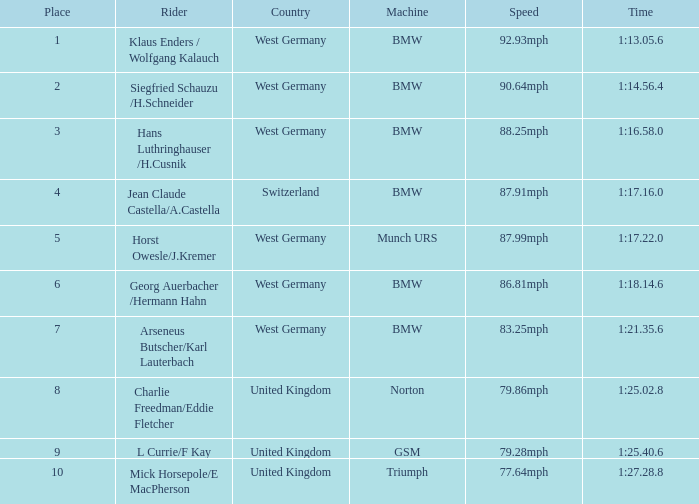Which places have points larger than 10? None. 